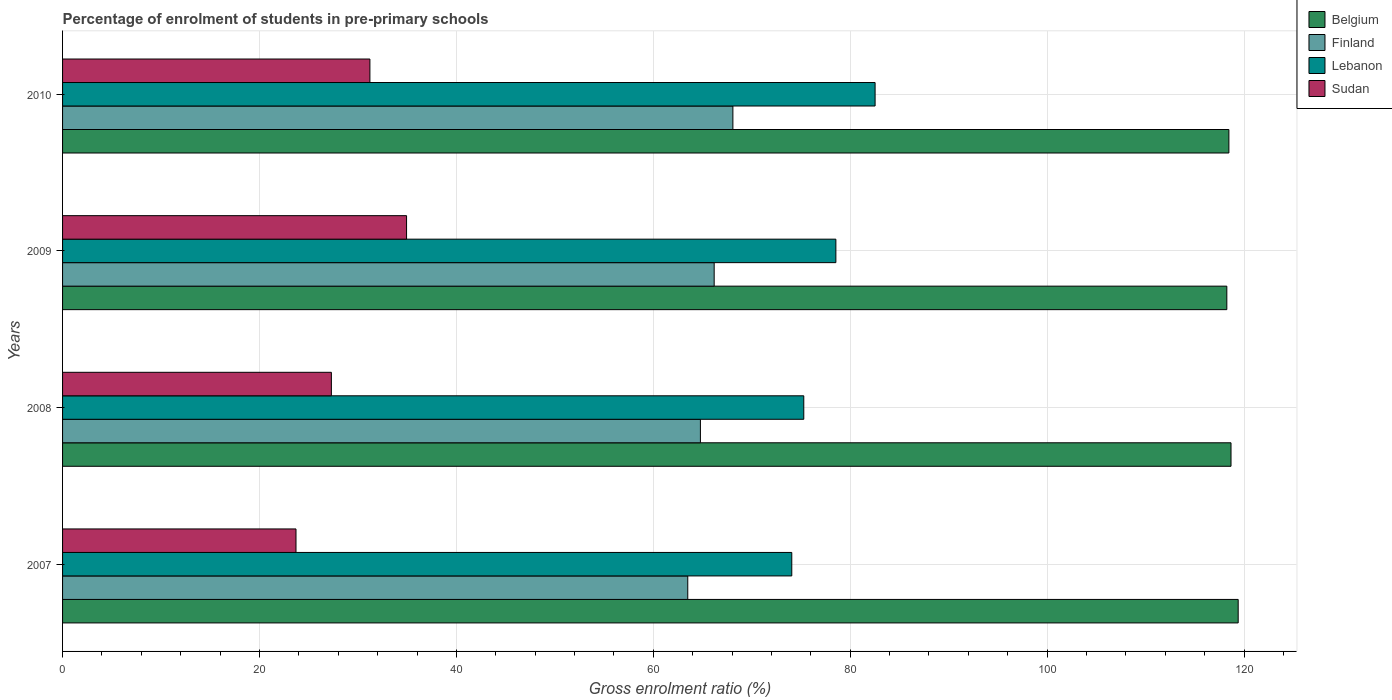How many different coloured bars are there?
Provide a short and direct response. 4. How many bars are there on the 4th tick from the bottom?
Keep it short and to the point. 4. What is the percentage of students enrolled in pre-primary schools in Lebanon in 2007?
Your answer should be compact. 74.07. Across all years, what is the maximum percentage of students enrolled in pre-primary schools in Sudan?
Offer a terse response. 34.94. Across all years, what is the minimum percentage of students enrolled in pre-primary schools in Finland?
Your answer should be compact. 63.5. In which year was the percentage of students enrolled in pre-primary schools in Lebanon maximum?
Make the answer very short. 2010. In which year was the percentage of students enrolled in pre-primary schools in Sudan minimum?
Provide a succinct answer. 2007. What is the total percentage of students enrolled in pre-primary schools in Sudan in the graph?
Offer a terse response. 117.17. What is the difference between the percentage of students enrolled in pre-primary schools in Sudan in 2009 and that in 2010?
Provide a short and direct response. 3.72. What is the difference between the percentage of students enrolled in pre-primary schools in Lebanon in 2008 and the percentage of students enrolled in pre-primary schools in Finland in 2007?
Offer a very short reply. 11.78. What is the average percentage of students enrolled in pre-primary schools in Belgium per year?
Your response must be concise. 118.7. In the year 2007, what is the difference between the percentage of students enrolled in pre-primary schools in Lebanon and percentage of students enrolled in pre-primary schools in Belgium?
Offer a terse response. -45.34. What is the ratio of the percentage of students enrolled in pre-primary schools in Lebanon in 2008 to that in 2010?
Your answer should be very brief. 0.91. Is the percentage of students enrolled in pre-primary schools in Finland in 2007 less than that in 2008?
Your answer should be compact. Yes. Is the difference between the percentage of students enrolled in pre-primary schools in Lebanon in 2009 and 2010 greater than the difference between the percentage of students enrolled in pre-primary schools in Belgium in 2009 and 2010?
Offer a terse response. No. What is the difference between the highest and the second highest percentage of students enrolled in pre-primary schools in Sudan?
Your answer should be very brief. 3.72. What is the difference between the highest and the lowest percentage of students enrolled in pre-primary schools in Belgium?
Keep it short and to the point. 1.15. In how many years, is the percentage of students enrolled in pre-primary schools in Belgium greater than the average percentage of students enrolled in pre-primary schools in Belgium taken over all years?
Keep it short and to the point. 1. Is the sum of the percentage of students enrolled in pre-primary schools in Sudan in 2007 and 2010 greater than the maximum percentage of students enrolled in pre-primary schools in Belgium across all years?
Provide a short and direct response. No. Is it the case that in every year, the sum of the percentage of students enrolled in pre-primary schools in Belgium and percentage of students enrolled in pre-primary schools in Finland is greater than the sum of percentage of students enrolled in pre-primary schools in Sudan and percentage of students enrolled in pre-primary schools in Lebanon?
Offer a terse response. No. What does the 2nd bar from the bottom in 2007 represents?
Provide a short and direct response. Finland. How many bars are there?
Offer a terse response. 16. Are all the bars in the graph horizontal?
Give a very brief answer. Yes. Are the values on the major ticks of X-axis written in scientific E-notation?
Offer a terse response. No. Does the graph contain any zero values?
Your answer should be compact. No. Does the graph contain grids?
Ensure brevity in your answer.  Yes. Where does the legend appear in the graph?
Ensure brevity in your answer.  Top right. How are the legend labels stacked?
Keep it short and to the point. Vertical. What is the title of the graph?
Provide a succinct answer. Percentage of enrolment of students in pre-primary schools. Does "Monaco" appear as one of the legend labels in the graph?
Offer a very short reply. No. What is the Gross enrolment ratio (%) in Belgium in 2007?
Your response must be concise. 119.41. What is the Gross enrolment ratio (%) in Finland in 2007?
Provide a succinct answer. 63.5. What is the Gross enrolment ratio (%) of Lebanon in 2007?
Keep it short and to the point. 74.07. What is the Gross enrolment ratio (%) of Sudan in 2007?
Make the answer very short. 23.71. What is the Gross enrolment ratio (%) of Belgium in 2008?
Offer a very short reply. 118.68. What is the Gross enrolment ratio (%) in Finland in 2008?
Offer a very short reply. 64.79. What is the Gross enrolment ratio (%) of Lebanon in 2008?
Your answer should be compact. 75.28. What is the Gross enrolment ratio (%) in Sudan in 2008?
Give a very brief answer. 27.3. What is the Gross enrolment ratio (%) in Belgium in 2009?
Offer a very short reply. 118.25. What is the Gross enrolment ratio (%) of Finland in 2009?
Your response must be concise. 66.18. What is the Gross enrolment ratio (%) of Lebanon in 2009?
Your answer should be very brief. 78.54. What is the Gross enrolment ratio (%) of Sudan in 2009?
Ensure brevity in your answer.  34.94. What is the Gross enrolment ratio (%) of Belgium in 2010?
Offer a very short reply. 118.46. What is the Gross enrolment ratio (%) in Finland in 2010?
Your answer should be very brief. 68.08. What is the Gross enrolment ratio (%) of Lebanon in 2010?
Ensure brevity in your answer.  82.53. What is the Gross enrolment ratio (%) of Sudan in 2010?
Provide a short and direct response. 31.22. Across all years, what is the maximum Gross enrolment ratio (%) of Belgium?
Provide a succinct answer. 119.41. Across all years, what is the maximum Gross enrolment ratio (%) in Finland?
Provide a short and direct response. 68.08. Across all years, what is the maximum Gross enrolment ratio (%) of Lebanon?
Keep it short and to the point. 82.53. Across all years, what is the maximum Gross enrolment ratio (%) in Sudan?
Offer a very short reply. 34.94. Across all years, what is the minimum Gross enrolment ratio (%) in Belgium?
Ensure brevity in your answer.  118.25. Across all years, what is the minimum Gross enrolment ratio (%) in Finland?
Provide a short and direct response. 63.5. Across all years, what is the minimum Gross enrolment ratio (%) of Lebanon?
Provide a succinct answer. 74.07. Across all years, what is the minimum Gross enrolment ratio (%) in Sudan?
Your answer should be compact. 23.71. What is the total Gross enrolment ratio (%) of Belgium in the graph?
Provide a succinct answer. 474.8. What is the total Gross enrolment ratio (%) of Finland in the graph?
Keep it short and to the point. 262.55. What is the total Gross enrolment ratio (%) in Lebanon in the graph?
Your answer should be very brief. 310.42. What is the total Gross enrolment ratio (%) of Sudan in the graph?
Your response must be concise. 117.17. What is the difference between the Gross enrolment ratio (%) of Belgium in 2007 and that in 2008?
Your answer should be compact. 0.73. What is the difference between the Gross enrolment ratio (%) in Finland in 2007 and that in 2008?
Your response must be concise. -1.28. What is the difference between the Gross enrolment ratio (%) of Lebanon in 2007 and that in 2008?
Your answer should be compact. -1.22. What is the difference between the Gross enrolment ratio (%) of Sudan in 2007 and that in 2008?
Your answer should be compact. -3.59. What is the difference between the Gross enrolment ratio (%) of Belgium in 2007 and that in 2009?
Provide a short and direct response. 1.15. What is the difference between the Gross enrolment ratio (%) in Finland in 2007 and that in 2009?
Give a very brief answer. -2.68. What is the difference between the Gross enrolment ratio (%) of Lebanon in 2007 and that in 2009?
Provide a succinct answer. -4.48. What is the difference between the Gross enrolment ratio (%) of Sudan in 2007 and that in 2009?
Give a very brief answer. -11.23. What is the difference between the Gross enrolment ratio (%) of Belgium in 2007 and that in 2010?
Give a very brief answer. 0.94. What is the difference between the Gross enrolment ratio (%) in Finland in 2007 and that in 2010?
Offer a terse response. -4.58. What is the difference between the Gross enrolment ratio (%) of Lebanon in 2007 and that in 2010?
Your answer should be compact. -8.46. What is the difference between the Gross enrolment ratio (%) in Sudan in 2007 and that in 2010?
Your response must be concise. -7.51. What is the difference between the Gross enrolment ratio (%) in Belgium in 2008 and that in 2009?
Your answer should be very brief. 0.42. What is the difference between the Gross enrolment ratio (%) in Finland in 2008 and that in 2009?
Provide a short and direct response. -1.4. What is the difference between the Gross enrolment ratio (%) of Lebanon in 2008 and that in 2009?
Keep it short and to the point. -3.26. What is the difference between the Gross enrolment ratio (%) of Sudan in 2008 and that in 2009?
Ensure brevity in your answer.  -7.64. What is the difference between the Gross enrolment ratio (%) in Belgium in 2008 and that in 2010?
Ensure brevity in your answer.  0.22. What is the difference between the Gross enrolment ratio (%) in Finland in 2008 and that in 2010?
Keep it short and to the point. -3.3. What is the difference between the Gross enrolment ratio (%) in Lebanon in 2008 and that in 2010?
Your answer should be very brief. -7.24. What is the difference between the Gross enrolment ratio (%) of Sudan in 2008 and that in 2010?
Ensure brevity in your answer.  -3.91. What is the difference between the Gross enrolment ratio (%) in Belgium in 2009 and that in 2010?
Provide a short and direct response. -0.21. What is the difference between the Gross enrolment ratio (%) of Finland in 2009 and that in 2010?
Offer a very short reply. -1.9. What is the difference between the Gross enrolment ratio (%) of Lebanon in 2009 and that in 2010?
Offer a terse response. -3.98. What is the difference between the Gross enrolment ratio (%) of Sudan in 2009 and that in 2010?
Offer a very short reply. 3.72. What is the difference between the Gross enrolment ratio (%) in Belgium in 2007 and the Gross enrolment ratio (%) in Finland in 2008?
Ensure brevity in your answer.  54.62. What is the difference between the Gross enrolment ratio (%) of Belgium in 2007 and the Gross enrolment ratio (%) of Lebanon in 2008?
Keep it short and to the point. 44.12. What is the difference between the Gross enrolment ratio (%) in Belgium in 2007 and the Gross enrolment ratio (%) in Sudan in 2008?
Keep it short and to the point. 92.1. What is the difference between the Gross enrolment ratio (%) of Finland in 2007 and the Gross enrolment ratio (%) of Lebanon in 2008?
Offer a very short reply. -11.78. What is the difference between the Gross enrolment ratio (%) in Finland in 2007 and the Gross enrolment ratio (%) in Sudan in 2008?
Your response must be concise. 36.2. What is the difference between the Gross enrolment ratio (%) of Lebanon in 2007 and the Gross enrolment ratio (%) of Sudan in 2008?
Your response must be concise. 46.76. What is the difference between the Gross enrolment ratio (%) of Belgium in 2007 and the Gross enrolment ratio (%) of Finland in 2009?
Provide a short and direct response. 53.22. What is the difference between the Gross enrolment ratio (%) of Belgium in 2007 and the Gross enrolment ratio (%) of Lebanon in 2009?
Make the answer very short. 40.86. What is the difference between the Gross enrolment ratio (%) in Belgium in 2007 and the Gross enrolment ratio (%) in Sudan in 2009?
Offer a terse response. 84.47. What is the difference between the Gross enrolment ratio (%) in Finland in 2007 and the Gross enrolment ratio (%) in Lebanon in 2009?
Your answer should be compact. -15.04. What is the difference between the Gross enrolment ratio (%) of Finland in 2007 and the Gross enrolment ratio (%) of Sudan in 2009?
Your response must be concise. 28.56. What is the difference between the Gross enrolment ratio (%) of Lebanon in 2007 and the Gross enrolment ratio (%) of Sudan in 2009?
Your response must be concise. 39.13. What is the difference between the Gross enrolment ratio (%) of Belgium in 2007 and the Gross enrolment ratio (%) of Finland in 2010?
Make the answer very short. 51.32. What is the difference between the Gross enrolment ratio (%) in Belgium in 2007 and the Gross enrolment ratio (%) in Lebanon in 2010?
Your answer should be compact. 36.88. What is the difference between the Gross enrolment ratio (%) in Belgium in 2007 and the Gross enrolment ratio (%) in Sudan in 2010?
Keep it short and to the point. 88.19. What is the difference between the Gross enrolment ratio (%) of Finland in 2007 and the Gross enrolment ratio (%) of Lebanon in 2010?
Provide a succinct answer. -19.03. What is the difference between the Gross enrolment ratio (%) in Finland in 2007 and the Gross enrolment ratio (%) in Sudan in 2010?
Provide a short and direct response. 32.29. What is the difference between the Gross enrolment ratio (%) in Lebanon in 2007 and the Gross enrolment ratio (%) in Sudan in 2010?
Give a very brief answer. 42.85. What is the difference between the Gross enrolment ratio (%) in Belgium in 2008 and the Gross enrolment ratio (%) in Finland in 2009?
Provide a short and direct response. 52.49. What is the difference between the Gross enrolment ratio (%) of Belgium in 2008 and the Gross enrolment ratio (%) of Lebanon in 2009?
Make the answer very short. 40.13. What is the difference between the Gross enrolment ratio (%) in Belgium in 2008 and the Gross enrolment ratio (%) in Sudan in 2009?
Make the answer very short. 83.74. What is the difference between the Gross enrolment ratio (%) of Finland in 2008 and the Gross enrolment ratio (%) of Lebanon in 2009?
Provide a short and direct response. -13.76. What is the difference between the Gross enrolment ratio (%) in Finland in 2008 and the Gross enrolment ratio (%) in Sudan in 2009?
Offer a terse response. 29.85. What is the difference between the Gross enrolment ratio (%) in Lebanon in 2008 and the Gross enrolment ratio (%) in Sudan in 2009?
Provide a succinct answer. 40.34. What is the difference between the Gross enrolment ratio (%) in Belgium in 2008 and the Gross enrolment ratio (%) in Finland in 2010?
Provide a succinct answer. 50.59. What is the difference between the Gross enrolment ratio (%) in Belgium in 2008 and the Gross enrolment ratio (%) in Lebanon in 2010?
Make the answer very short. 36.15. What is the difference between the Gross enrolment ratio (%) of Belgium in 2008 and the Gross enrolment ratio (%) of Sudan in 2010?
Your response must be concise. 87.46. What is the difference between the Gross enrolment ratio (%) in Finland in 2008 and the Gross enrolment ratio (%) in Lebanon in 2010?
Offer a very short reply. -17.74. What is the difference between the Gross enrolment ratio (%) of Finland in 2008 and the Gross enrolment ratio (%) of Sudan in 2010?
Your response must be concise. 33.57. What is the difference between the Gross enrolment ratio (%) in Lebanon in 2008 and the Gross enrolment ratio (%) in Sudan in 2010?
Provide a succinct answer. 44.07. What is the difference between the Gross enrolment ratio (%) in Belgium in 2009 and the Gross enrolment ratio (%) in Finland in 2010?
Provide a short and direct response. 50.17. What is the difference between the Gross enrolment ratio (%) of Belgium in 2009 and the Gross enrolment ratio (%) of Lebanon in 2010?
Make the answer very short. 35.72. What is the difference between the Gross enrolment ratio (%) of Belgium in 2009 and the Gross enrolment ratio (%) of Sudan in 2010?
Keep it short and to the point. 87.04. What is the difference between the Gross enrolment ratio (%) in Finland in 2009 and the Gross enrolment ratio (%) in Lebanon in 2010?
Ensure brevity in your answer.  -16.34. What is the difference between the Gross enrolment ratio (%) of Finland in 2009 and the Gross enrolment ratio (%) of Sudan in 2010?
Your answer should be very brief. 34.97. What is the difference between the Gross enrolment ratio (%) of Lebanon in 2009 and the Gross enrolment ratio (%) of Sudan in 2010?
Give a very brief answer. 47.33. What is the average Gross enrolment ratio (%) of Belgium per year?
Keep it short and to the point. 118.7. What is the average Gross enrolment ratio (%) of Finland per year?
Keep it short and to the point. 65.64. What is the average Gross enrolment ratio (%) of Lebanon per year?
Offer a terse response. 77.61. What is the average Gross enrolment ratio (%) in Sudan per year?
Provide a succinct answer. 29.29. In the year 2007, what is the difference between the Gross enrolment ratio (%) in Belgium and Gross enrolment ratio (%) in Finland?
Make the answer very short. 55.91. In the year 2007, what is the difference between the Gross enrolment ratio (%) in Belgium and Gross enrolment ratio (%) in Lebanon?
Your answer should be compact. 45.34. In the year 2007, what is the difference between the Gross enrolment ratio (%) of Belgium and Gross enrolment ratio (%) of Sudan?
Your answer should be very brief. 95.7. In the year 2007, what is the difference between the Gross enrolment ratio (%) of Finland and Gross enrolment ratio (%) of Lebanon?
Ensure brevity in your answer.  -10.56. In the year 2007, what is the difference between the Gross enrolment ratio (%) of Finland and Gross enrolment ratio (%) of Sudan?
Ensure brevity in your answer.  39.79. In the year 2007, what is the difference between the Gross enrolment ratio (%) in Lebanon and Gross enrolment ratio (%) in Sudan?
Provide a succinct answer. 50.36. In the year 2008, what is the difference between the Gross enrolment ratio (%) in Belgium and Gross enrolment ratio (%) in Finland?
Your response must be concise. 53.89. In the year 2008, what is the difference between the Gross enrolment ratio (%) of Belgium and Gross enrolment ratio (%) of Lebanon?
Ensure brevity in your answer.  43.39. In the year 2008, what is the difference between the Gross enrolment ratio (%) in Belgium and Gross enrolment ratio (%) in Sudan?
Ensure brevity in your answer.  91.37. In the year 2008, what is the difference between the Gross enrolment ratio (%) of Finland and Gross enrolment ratio (%) of Lebanon?
Your answer should be very brief. -10.5. In the year 2008, what is the difference between the Gross enrolment ratio (%) of Finland and Gross enrolment ratio (%) of Sudan?
Provide a succinct answer. 37.48. In the year 2008, what is the difference between the Gross enrolment ratio (%) of Lebanon and Gross enrolment ratio (%) of Sudan?
Keep it short and to the point. 47.98. In the year 2009, what is the difference between the Gross enrolment ratio (%) in Belgium and Gross enrolment ratio (%) in Finland?
Offer a very short reply. 52.07. In the year 2009, what is the difference between the Gross enrolment ratio (%) of Belgium and Gross enrolment ratio (%) of Lebanon?
Provide a succinct answer. 39.71. In the year 2009, what is the difference between the Gross enrolment ratio (%) of Belgium and Gross enrolment ratio (%) of Sudan?
Offer a very short reply. 83.31. In the year 2009, what is the difference between the Gross enrolment ratio (%) in Finland and Gross enrolment ratio (%) in Lebanon?
Make the answer very short. -12.36. In the year 2009, what is the difference between the Gross enrolment ratio (%) of Finland and Gross enrolment ratio (%) of Sudan?
Provide a short and direct response. 31.24. In the year 2009, what is the difference between the Gross enrolment ratio (%) in Lebanon and Gross enrolment ratio (%) in Sudan?
Keep it short and to the point. 43.6. In the year 2010, what is the difference between the Gross enrolment ratio (%) of Belgium and Gross enrolment ratio (%) of Finland?
Give a very brief answer. 50.38. In the year 2010, what is the difference between the Gross enrolment ratio (%) in Belgium and Gross enrolment ratio (%) in Lebanon?
Offer a terse response. 35.93. In the year 2010, what is the difference between the Gross enrolment ratio (%) in Belgium and Gross enrolment ratio (%) in Sudan?
Offer a very short reply. 87.25. In the year 2010, what is the difference between the Gross enrolment ratio (%) in Finland and Gross enrolment ratio (%) in Lebanon?
Make the answer very short. -14.44. In the year 2010, what is the difference between the Gross enrolment ratio (%) in Finland and Gross enrolment ratio (%) in Sudan?
Your answer should be very brief. 36.87. In the year 2010, what is the difference between the Gross enrolment ratio (%) in Lebanon and Gross enrolment ratio (%) in Sudan?
Provide a succinct answer. 51.31. What is the ratio of the Gross enrolment ratio (%) of Finland in 2007 to that in 2008?
Your answer should be very brief. 0.98. What is the ratio of the Gross enrolment ratio (%) in Lebanon in 2007 to that in 2008?
Your answer should be very brief. 0.98. What is the ratio of the Gross enrolment ratio (%) of Sudan in 2007 to that in 2008?
Your response must be concise. 0.87. What is the ratio of the Gross enrolment ratio (%) in Belgium in 2007 to that in 2009?
Make the answer very short. 1.01. What is the ratio of the Gross enrolment ratio (%) of Finland in 2007 to that in 2009?
Your response must be concise. 0.96. What is the ratio of the Gross enrolment ratio (%) in Lebanon in 2007 to that in 2009?
Offer a very short reply. 0.94. What is the ratio of the Gross enrolment ratio (%) of Sudan in 2007 to that in 2009?
Offer a terse response. 0.68. What is the ratio of the Gross enrolment ratio (%) of Belgium in 2007 to that in 2010?
Ensure brevity in your answer.  1.01. What is the ratio of the Gross enrolment ratio (%) in Finland in 2007 to that in 2010?
Ensure brevity in your answer.  0.93. What is the ratio of the Gross enrolment ratio (%) of Lebanon in 2007 to that in 2010?
Offer a very short reply. 0.9. What is the ratio of the Gross enrolment ratio (%) in Sudan in 2007 to that in 2010?
Offer a terse response. 0.76. What is the ratio of the Gross enrolment ratio (%) in Belgium in 2008 to that in 2009?
Your answer should be very brief. 1. What is the ratio of the Gross enrolment ratio (%) of Finland in 2008 to that in 2009?
Your response must be concise. 0.98. What is the ratio of the Gross enrolment ratio (%) of Lebanon in 2008 to that in 2009?
Offer a very short reply. 0.96. What is the ratio of the Gross enrolment ratio (%) of Sudan in 2008 to that in 2009?
Make the answer very short. 0.78. What is the ratio of the Gross enrolment ratio (%) of Belgium in 2008 to that in 2010?
Give a very brief answer. 1. What is the ratio of the Gross enrolment ratio (%) of Finland in 2008 to that in 2010?
Give a very brief answer. 0.95. What is the ratio of the Gross enrolment ratio (%) in Lebanon in 2008 to that in 2010?
Give a very brief answer. 0.91. What is the ratio of the Gross enrolment ratio (%) in Sudan in 2008 to that in 2010?
Make the answer very short. 0.87. What is the ratio of the Gross enrolment ratio (%) in Finland in 2009 to that in 2010?
Ensure brevity in your answer.  0.97. What is the ratio of the Gross enrolment ratio (%) of Lebanon in 2009 to that in 2010?
Provide a succinct answer. 0.95. What is the ratio of the Gross enrolment ratio (%) of Sudan in 2009 to that in 2010?
Your answer should be very brief. 1.12. What is the difference between the highest and the second highest Gross enrolment ratio (%) in Belgium?
Your response must be concise. 0.73. What is the difference between the highest and the second highest Gross enrolment ratio (%) of Finland?
Make the answer very short. 1.9. What is the difference between the highest and the second highest Gross enrolment ratio (%) of Lebanon?
Provide a succinct answer. 3.98. What is the difference between the highest and the second highest Gross enrolment ratio (%) in Sudan?
Offer a very short reply. 3.72. What is the difference between the highest and the lowest Gross enrolment ratio (%) of Belgium?
Your answer should be very brief. 1.15. What is the difference between the highest and the lowest Gross enrolment ratio (%) of Finland?
Make the answer very short. 4.58. What is the difference between the highest and the lowest Gross enrolment ratio (%) in Lebanon?
Make the answer very short. 8.46. What is the difference between the highest and the lowest Gross enrolment ratio (%) in Sudan?
Make the answer very short. 11.23. 